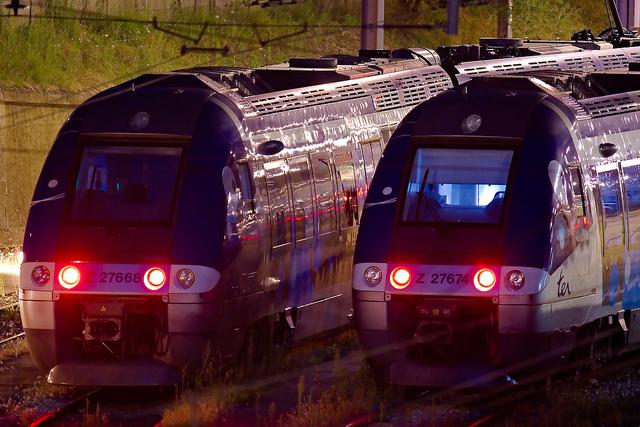Are these passenger trains?
Concise answer only. Yes. Are the headlights on?
Quick response, please. Yes. What number is on the train on the right?
Quick response, please. 27674. 